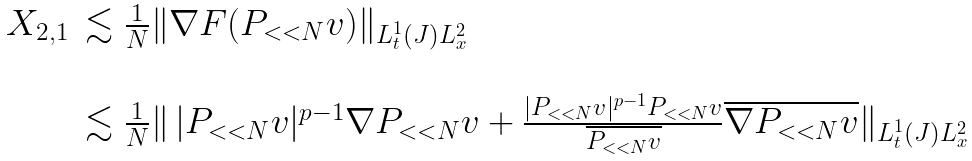<formula> <loc_0><loc_0><loc_500><loc_500>\begin{array} { l l } X _ { 2 , 1 } & \lesssim \frac { 1 } { N } \| \nabla F ( P _ { < < N } v ) \| _ { L _ { t } ^ { 1 } ( J ) L _ { x } ^ { 2 } } \\ & \\ & \lesssim \frac { 1 } { N } \| \, | P _ { < < N } v | ^ { p - 1 } \nabla P _ { < < N } v + \frac { | P _ { < < N } v | ^ { p - 1 } P _ { < < N } v } { \overline { P _ { < < N } v } } \overline { \nabla P _ { < < N } v } \| _ { L _ { t } ^ { 1 } ( J ) L _ { x } ^ { 2 } } \end{array}</formula> 